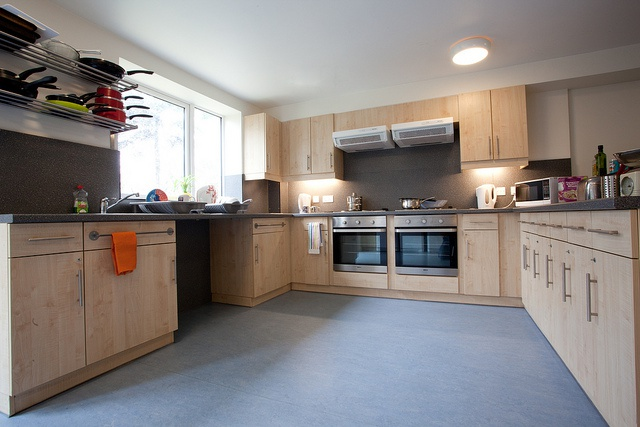Describe the objects in this image and their specific colors. I can see oven in gray, black, darkgray, and blue tones, oven in gray, black, and darkgray tones, microwave in gray, black, lightgray, and maroon tones, sink in gray, black, and darkgray tones, and bottle in gray, black, olive, and maroon tones in this image. 